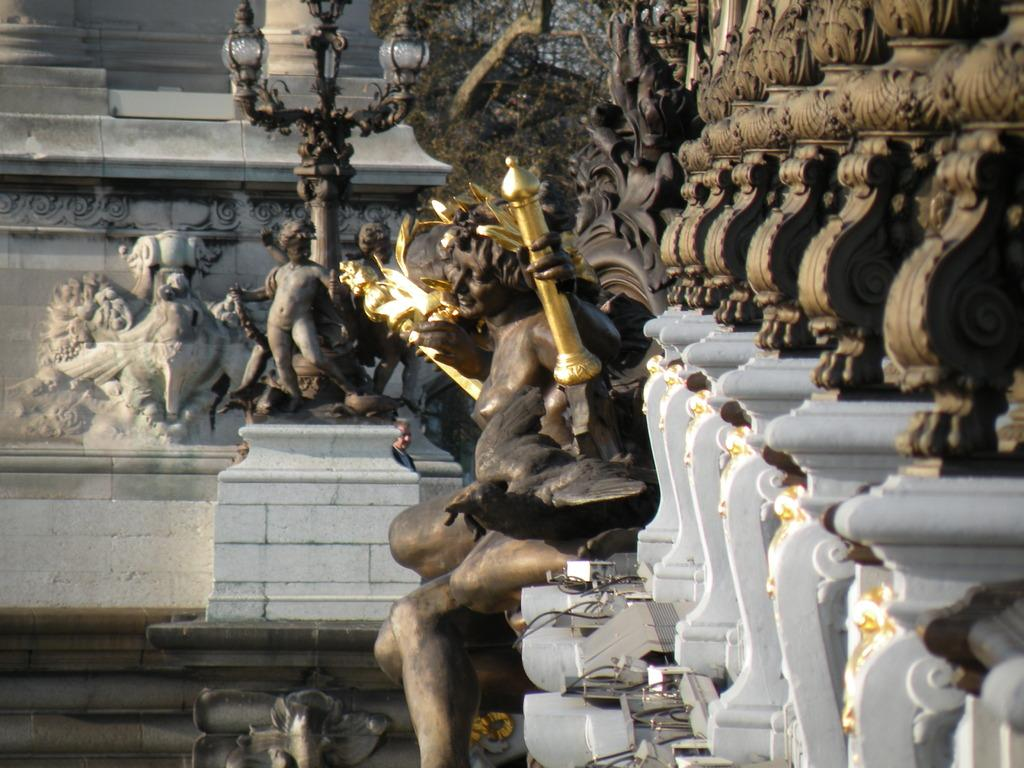What is the main subject in the center of the image? There are sculptures in the center of the image. What type of barrier can be seen in the image? There are fences in the image. What other objects are present in the image besides the sculptures and fences? There are other objects in the image. What can be seen in the background of the image? There is a wall visible in the background of the image. What type of pleasure can be seen on the faces of the sculptures in the image? There are no faces on the sculptures in the image, so it is not possible to determine if they are experiencing pleasure or any other emotion. 